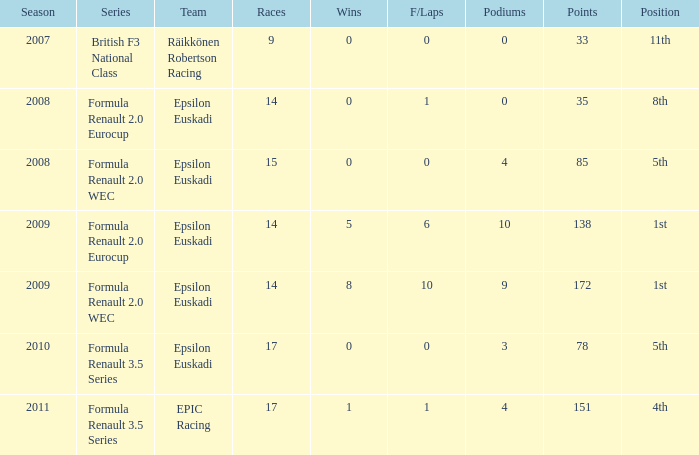What team was he on when he had 10 f/laps? Epsilon Euskadi. 